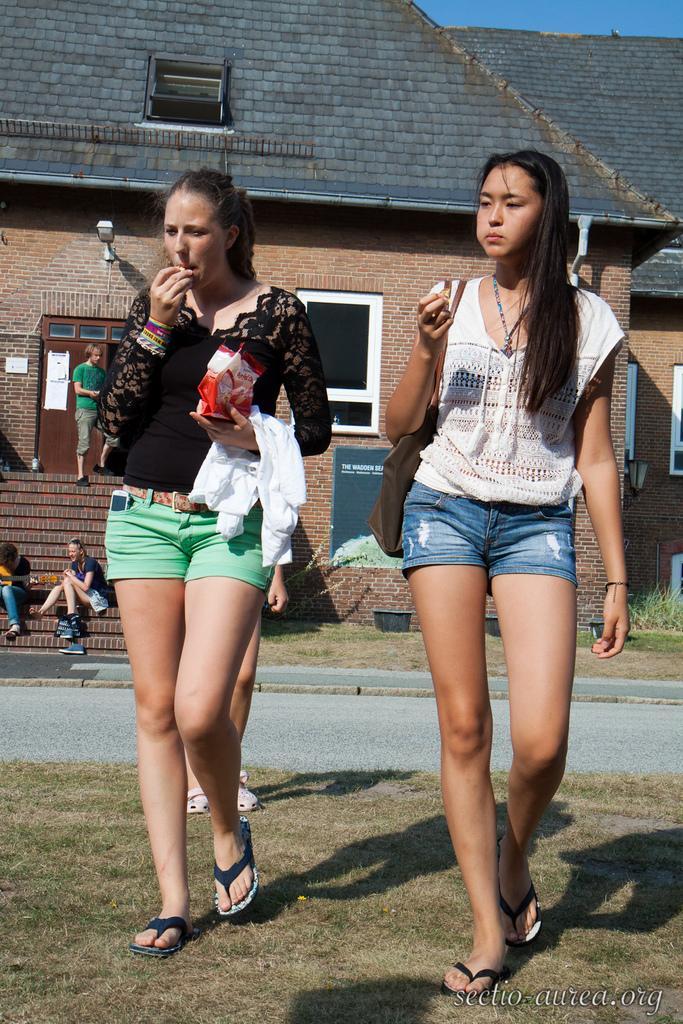Please provide a concise description of this image. In this image we can see women walking on the grass and one of them is holding packaged food in the hands. In the background there are people standing on the stairs, people sitting on the stairs, street lights, doors, windows, buildings and sky. 